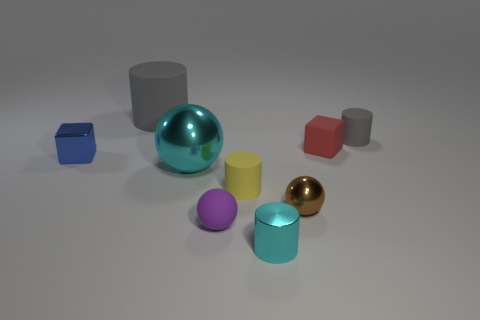Subtract all yellow rubber cylinders. How many cylinders are left? 3 Subtract all brown spheres. How many spheres are left? 2 Subtract all brown blocks. How many gray cylinders are left? 2 Subtract all blocks. How many objects are left? 7 Subtract 3 cylinders. How many cylinders are left? 1 Add 1 small brown objects. How many objects exist? 10 Subtract all cyan blocks. Subtract all cyan cylinders. How many blocks are left? 2 Subtract all red objects. Subtract all red shiny cylinders. How many objects are left? 8 Add 4 tiny red rubber things. How many tiny red rubber things are left? 5 Add 6 tiny cyan metallic cylinders. How many tiny cyan metallic cylinders exist? 7 